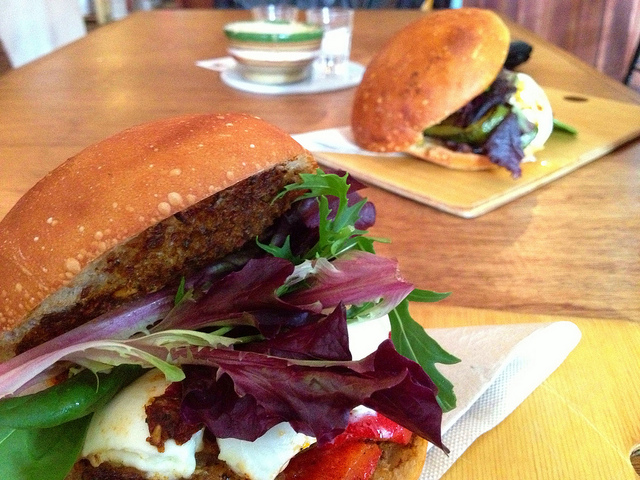Can you tell me more about the types of sandwiches shown in the image? Certainly! The sandwich in the foreground appears to be a vegetarian option with a hearty veggie patty, topped with fresh mixed greens and a creamy sauce. The other sandwich in the background seems to feature grilled vegetables, possibly including eggplant, and melted cheese, suggesting a warm and savory experience. 